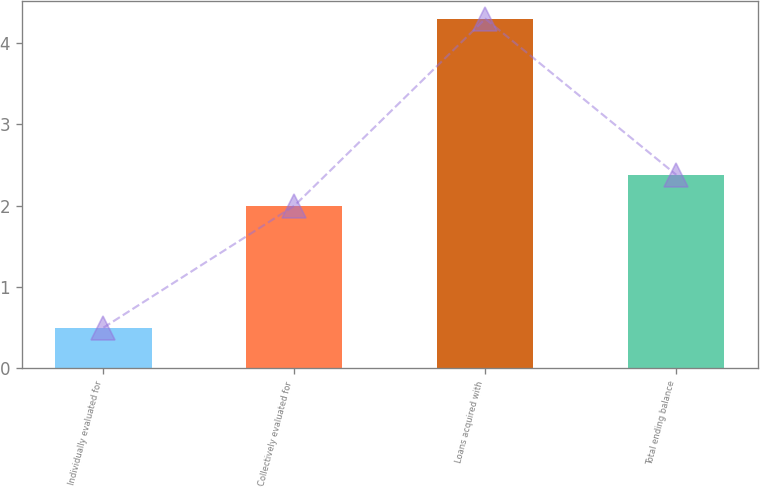<chart> <loc_0><loc_0><loc_500><loc_500><bar_chart><fcel>Individually evaluated for<fcel>Collectively evaluated for<fcel>Loans acquired with<fcel>Total ending balance<nl><fcel>0.5<fcel>2<fcel>4.3<fcel>2.38<nl></chart> 